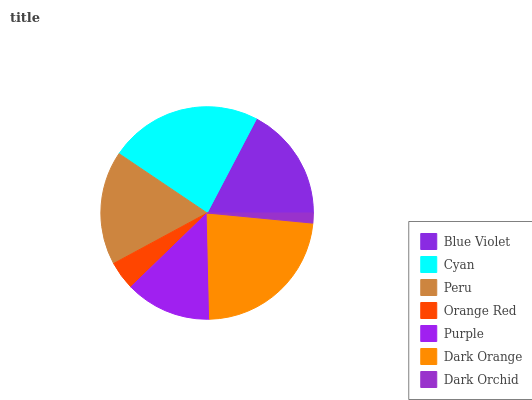Is Dark Orchid the minimum?
Answer yes or no. Yes. Is Cyan the maximum?
Answer yes or no. Yes. Is Peru the minimum?
Answer yes or no. No. Is Peru the maximum?
Answer yes or no. No. Is Cyan greater than Peru?
Answer yes or no. Yes. Is Peru less than Cyan?
Answer yes or no. Yes. Is Peru greater than Cyan?
Answer yes or no. No. Is Cyan less than Peru?
Answer yes or no. No. Is Blue Violet the high median?
Answer yes or no. Yes. Is Blue Violet the low median?
Answer yes or no. Yes. Is Orange Red the high median?
Answer yes or no. No. Is Cyan the low median?
Answer yes or no. No. 